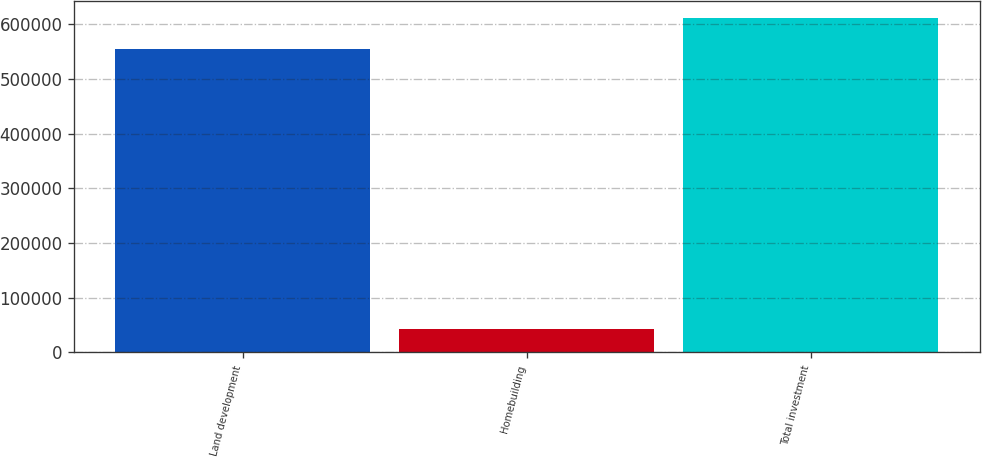Convert chart to OTSL. <chart><loc_0><loc_0><loc_500><loc_500><bar_chart><fcel>Land development<fcel>Homebuilding<fcel>Total investment<nl><fcel>555799<fcel>43467<fcel>611379<nl></chart> 